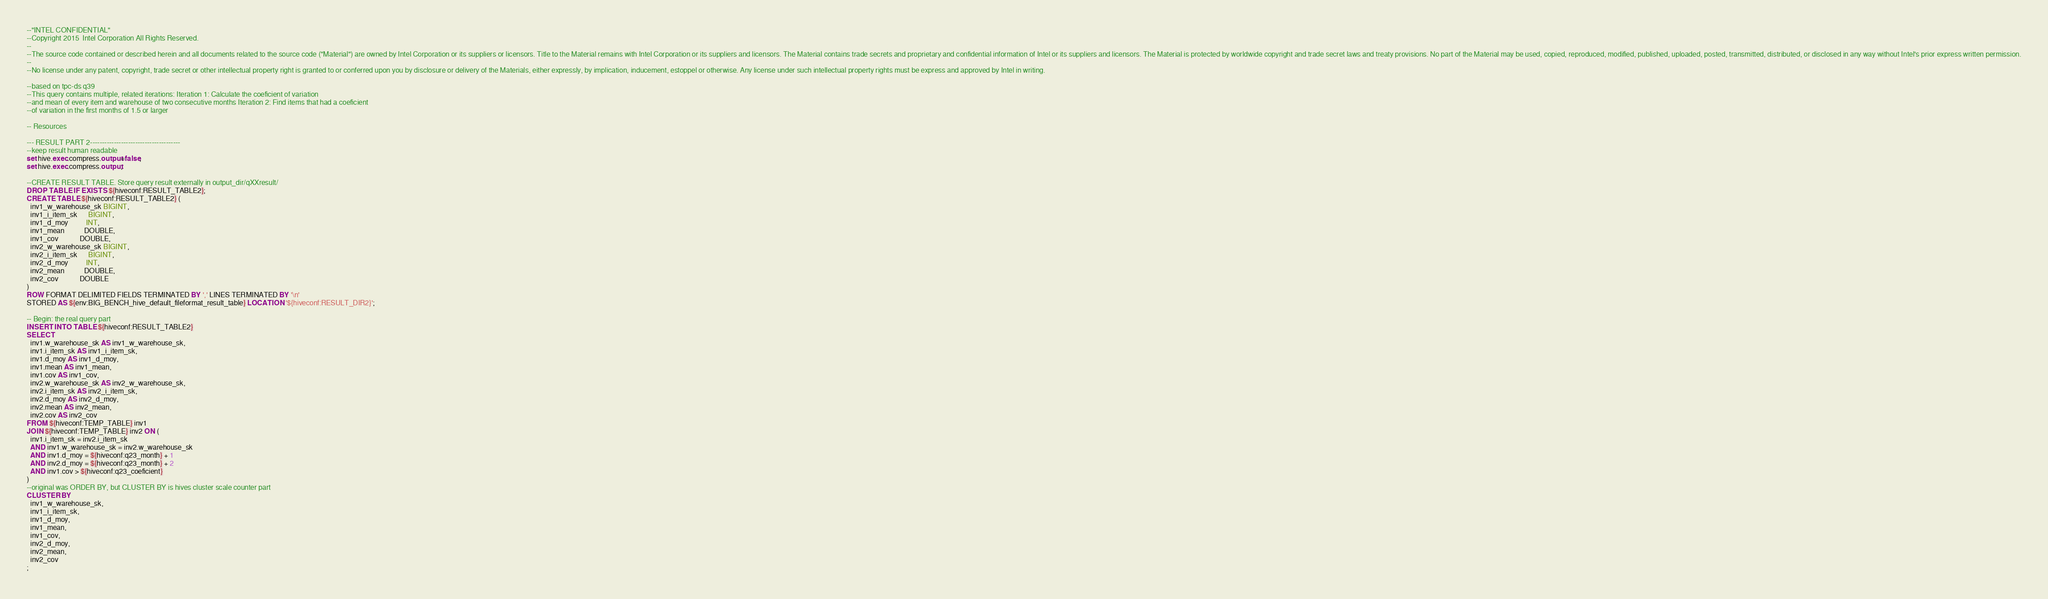<code> <loc_0><loc_0><loc_500><loc_500><_SQL_>--"INTEL CONFIDENTIAL"
--Copyright 2015  Intel Corporation All Rights Reserved.
--
--The source code contained or described herein and all documents related to the source code ("Material") are owned by Intel Corporation or its suppliers or licensors. Title to the Material remains with Intel Corporation or its suppliers and licensors. The Material contains trade secrets and proprietary and confidential information of Intel or its suppliers and licensors. The Material is protected by worldwide copyright and trade secret laws and treaty provisions. No part of the Material may be used, copied, reproduced, modified, published, uploaded, posted, transmitted, distributed, or disclosed in any way without Intel's prior express written permission.
--
--No license under any patent, copyright, trade secret or other intellectual property right is granted to or conferred upon you by disclosure or delivery of the Materials, either expressly, by implication, inducement, estoppel or otherwise. Any license under such intellectual property rights must be express and approved by Intel in writing.

--based on tpc-ds q39
--This query contains multiple, related iterations: Iteration 1: Calculate the coeficient of variation 
--and mean of every item and warehouse of two consecutive months Iteration 2: Find items that had a coeficient
--of variation in the first months of 1.5 or larger

-- Resources

--- RESULT PART 2--------------------------------------
--keep result human readable
set hive.exec.compress.output=false;
set hive.exec.compress.output;

--CREATE RESULT TABLE. Store query result externally in output_dir/qXXresult/
DROP TABLE IF EXISTS ${hiveconf:RESULT_TABLE2};
CREATE TABLE ${hiveconf:RESULT_TABLE2} (
  inv1_w_warehouse_sk BIGINT,
  inv1_i_item_sk      BIGINT,
  inv1_d_moy          INT,
  inv1_mean           DOUBLE,
  inv1_cov            DOUBLE,
  inv2_w_warehouse_sk BIGINT,
  inv2_i_item_sk      BIGINT,
  inv2_d_moy          INT,
  inv2_mean           DOUBLE,
  inv2_cov            DOUBLE
)
ROW FORMAT DELIMITED FIELDS TERMINATED BY ',' LINES TERMINATED BY '\n'
STORED AS ${env:BIG_BENCH_hive_default_fileformat_result_table} LOCATION '${hiveconf:RESULT_DIR2}';

-- Begin: the real query part
INSERT INTO TABLE ${hiveconf:RESULT_TABLE2}
SELECT
  inv1.w_warehouse_sk AS inv1_w_warehouse_sk,
  inv1.i_item_sk AS inv1_i_item_sk,
  inv1.d_moy AS inv1_d_moy,
  inv1.mean AS inv1_mean,
  inv1.cov AS inv1_cov,
  inv2.w_warehouse_sk AS inv2_w_warehouse_sk,
  inv2.i_item_sk AS inv2_i_item_sk,
  inv2.d_moy AS inv2_d_moy,
  inv2.mean AS inv2_mean,
  inv2.cov AS inv2_cov
FROM ${hiveconf:TEMP_TABLE} inv1
JOIN ${hiveconf:TEMP_TABLE} inv2 ON (
  inv1.i_item_sk = inv2.i_item_sk
  AND inv1.w_warehouse_sk = inv2.w_warehouse_sk
  AND inv1.d_moy = ${hiveconf:q23_month} + 1
  AND inv2.d_moy = ${hiveconf:q23_month} + 2
  AND inv1.cov > ${hiveconf:q23_coeficient}
)
--original was ORDER BY, but CLUSTER BY is hives cluster scale counter part
CLUSTER BY
  inv1_w_warehouse_sk,
  inv1_i_item_sk,
  inv1_d_moy,
  inv1_mean,
  inv1_cov,
  inv2_d_moy,
  inv2_mean,
  inv2_cov
;
</code> 